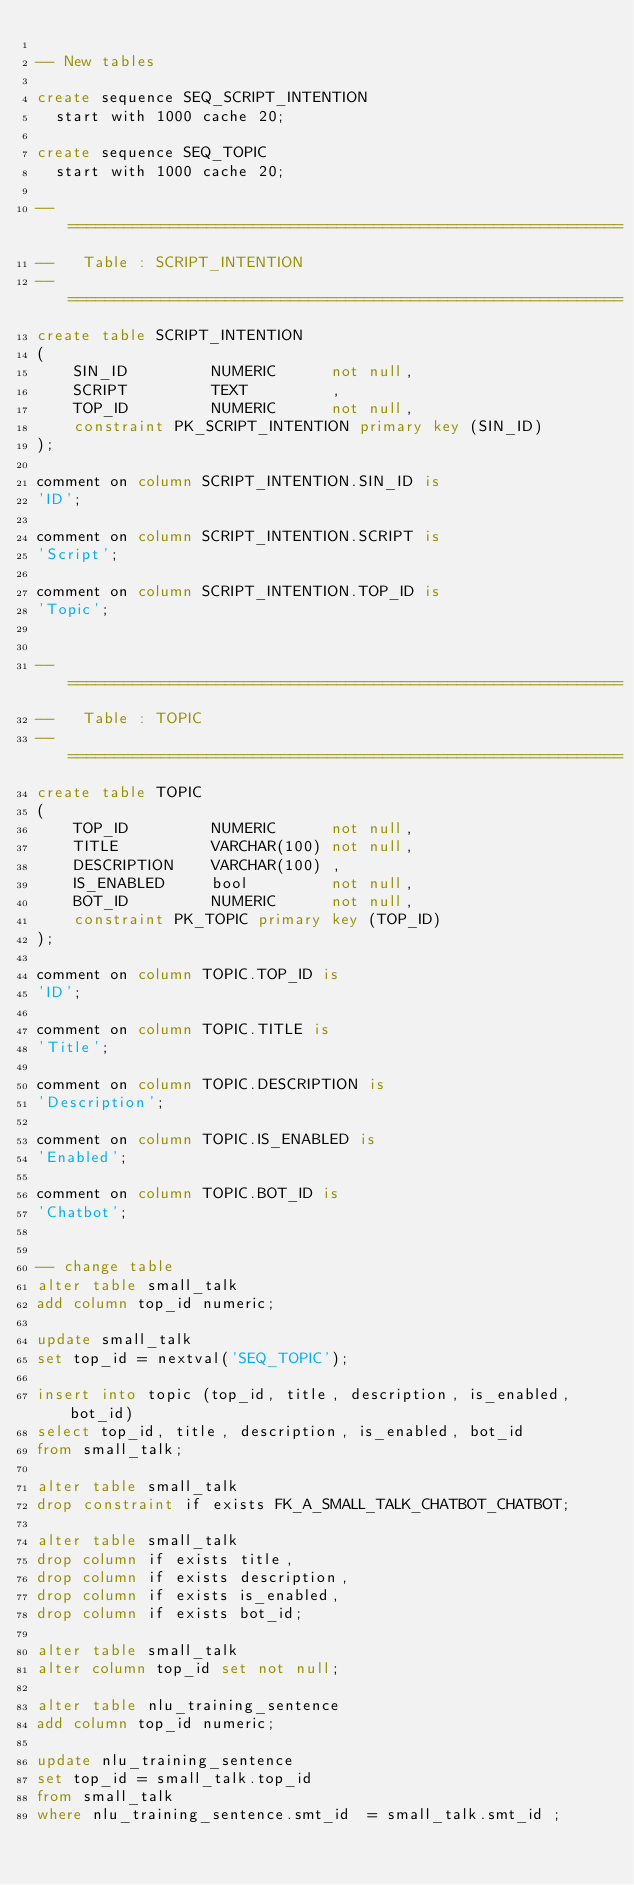Convert code to text. <code><loc_0><loc_0><loc_500><loc_500><_SQL_>
-- New tables

create sequence SEQ_SCRIPT_INTENTION
	start with 1000 cache 20; 
	
create sequence SEQ_TOPIC
	start with 1000 cache 20; 

-- ============================================================
--   Table : SCRIPT_INTENTION                                        
-- ============================================================
create table SCRIPT_INTENTION
(
    SIN_ID      	 NUMERIC     	not null,
    SCRIPT      	 TEXT        	,
    TOP_ID      	 NUMERIC     	not null,
    constraint PK_SCRIPT_INTENTION primary key (SIN_ID)
);

comment on column SCRIPT_INTENTION.SIN_ID is
'ID';

comment on column SCRIPT_INTENTION.SCRIPT is
'Script';

comment on column SCRIPT_INTENTION.TOP_ID is
'Topic';


-- ============================================================
--   Table : TOPIC                                        
-- ============================================================
create table TOPIC
(
    TOP_ID      	 NUMERIC     	not null,
    TITLE       	 VARCHAR(100)	not null,
    DESCRIPTION 	 VARCHAR(100)	,
    IS_ENABLED  	 bool        	not null,
    BOT_ID      	 NUMERIC     	not null,
    constraint PK_TOPIC primary key (TOP_ID)
);

comment on column TOPIC.TOP_ID is
'ID';

comment on column TOPIC.TITLE is
'Title';

comment on column TOPIC.DESCRIPTION is
'Description';

comment on column TOPIC.IS_ENABLED is
'Enabled';

comment on column TOPIC.BOT_ID is
'Chatbot';


-- change table
alter table small_talk 
add column top_id numeric;

update small_talk 
set top_id = nextval('SEQ_TOPIC');

insert into topic (top_id, title, description, is_enabled, bot_id)
select top_id, title, description, is_enabled, bot_id
from small_talk;

alter table small_talk 
drop constraint if exists FK_A_SMALL_TALK_CHATBOT_CHATBOT;

alter table small_talk 
drop column if exists title,
drop column if exists description,
drop column if exists is_enabled,
drop column if exists bot_id;

alter table small_talk
alter column top_id set not null;

alter table nlu_training_sentence 
add column top_id numeric;

update nlu_training_sentence 
set top_id = small_talk.top_id
from small_talk 
where nlu_training_sentence.smt_id  = small_talk.smt_id ; 
</code> 